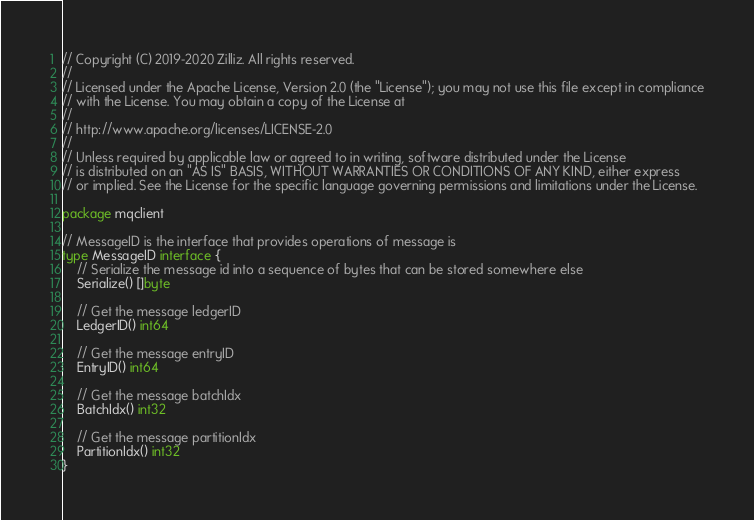Convert code to text. <code><loc_0><loc_0><loc_500><loc_500><_Go_>// Copyright (C) 2019-2020 Zilliz. All rights reserved.
//
// Licensed under the Apache License, Version 2.0 (the "License"); you may not use this file except in compliance
// with the License. You may obtain a copy of the License at
//
// http://www.apache.org/licenses/LICENSE-2.0
//
// Unless required by applicable law or agreed to in writing, software distributed under the License
// is distributed on an "AS IS" BASIS, WITHOUT WARRANTIES OR CONDITIONS OF ANY KIND, either express
// or implied. See the License for the specific language governing permissions and limitations under the License.

package mqclient

// MessageID is the interface that provides operations of message is
type MessageID interface {
	// Serialize the message id into a sequence of bytes that can be stored somewhere else
	Serialize() []byte

	// Get the message ledgerID
	LedgerID() int64

	// Get the message entryID
	EntryID() int64

	// Get the message batchIdx
	BatchIdx() int32

	// Get the message partitionIdx
	PartitionIdx() int32
}
</code> 